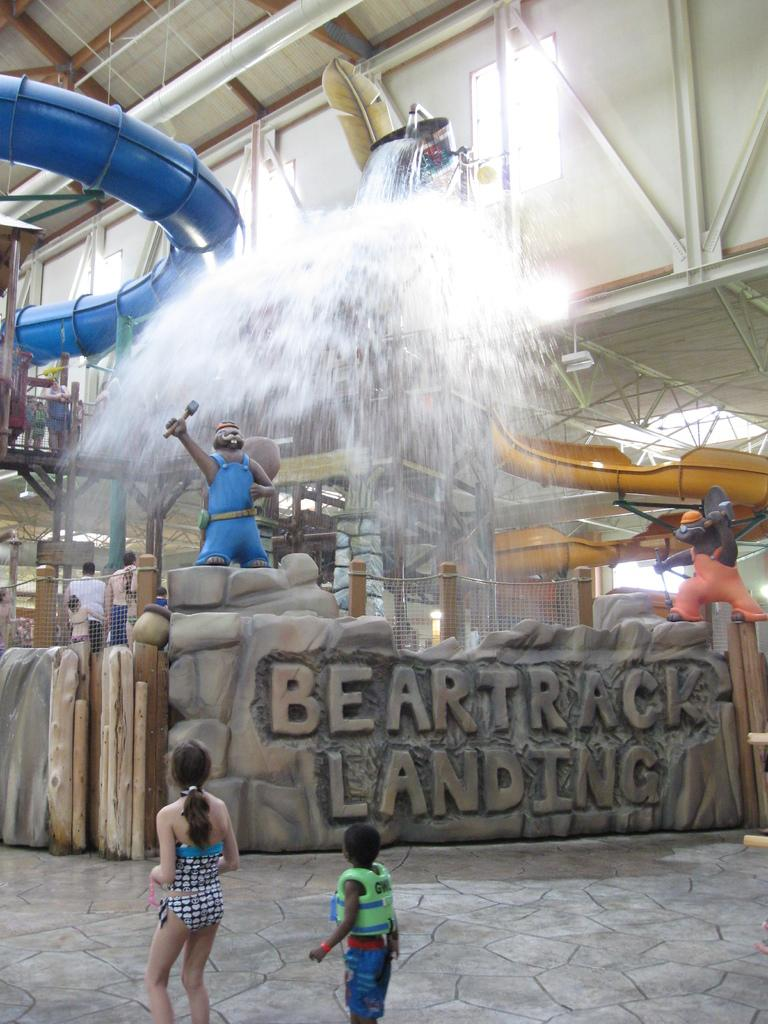What can be seen in the image? There are people standing in the image. What is visible in the background of the image? There is water, water slides, two statues, and iron poles visible in the background of the image. What type of insect can be seen crawling on the quill in the image? There is no insect or quill present in the image. 